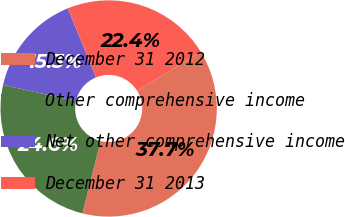Convert chart. <chart><loc_0><loc_0><loc_500><loc_500><pie_chart><fcel>December 31 2012<fcel>Other comprehensive income<fcel>Net other comprehensive income<fcel>December 31 2013<nl><fcel>37.7%<fcel>24.6%<fcel>15.34%<fcel>22.36%<nl></chart> 